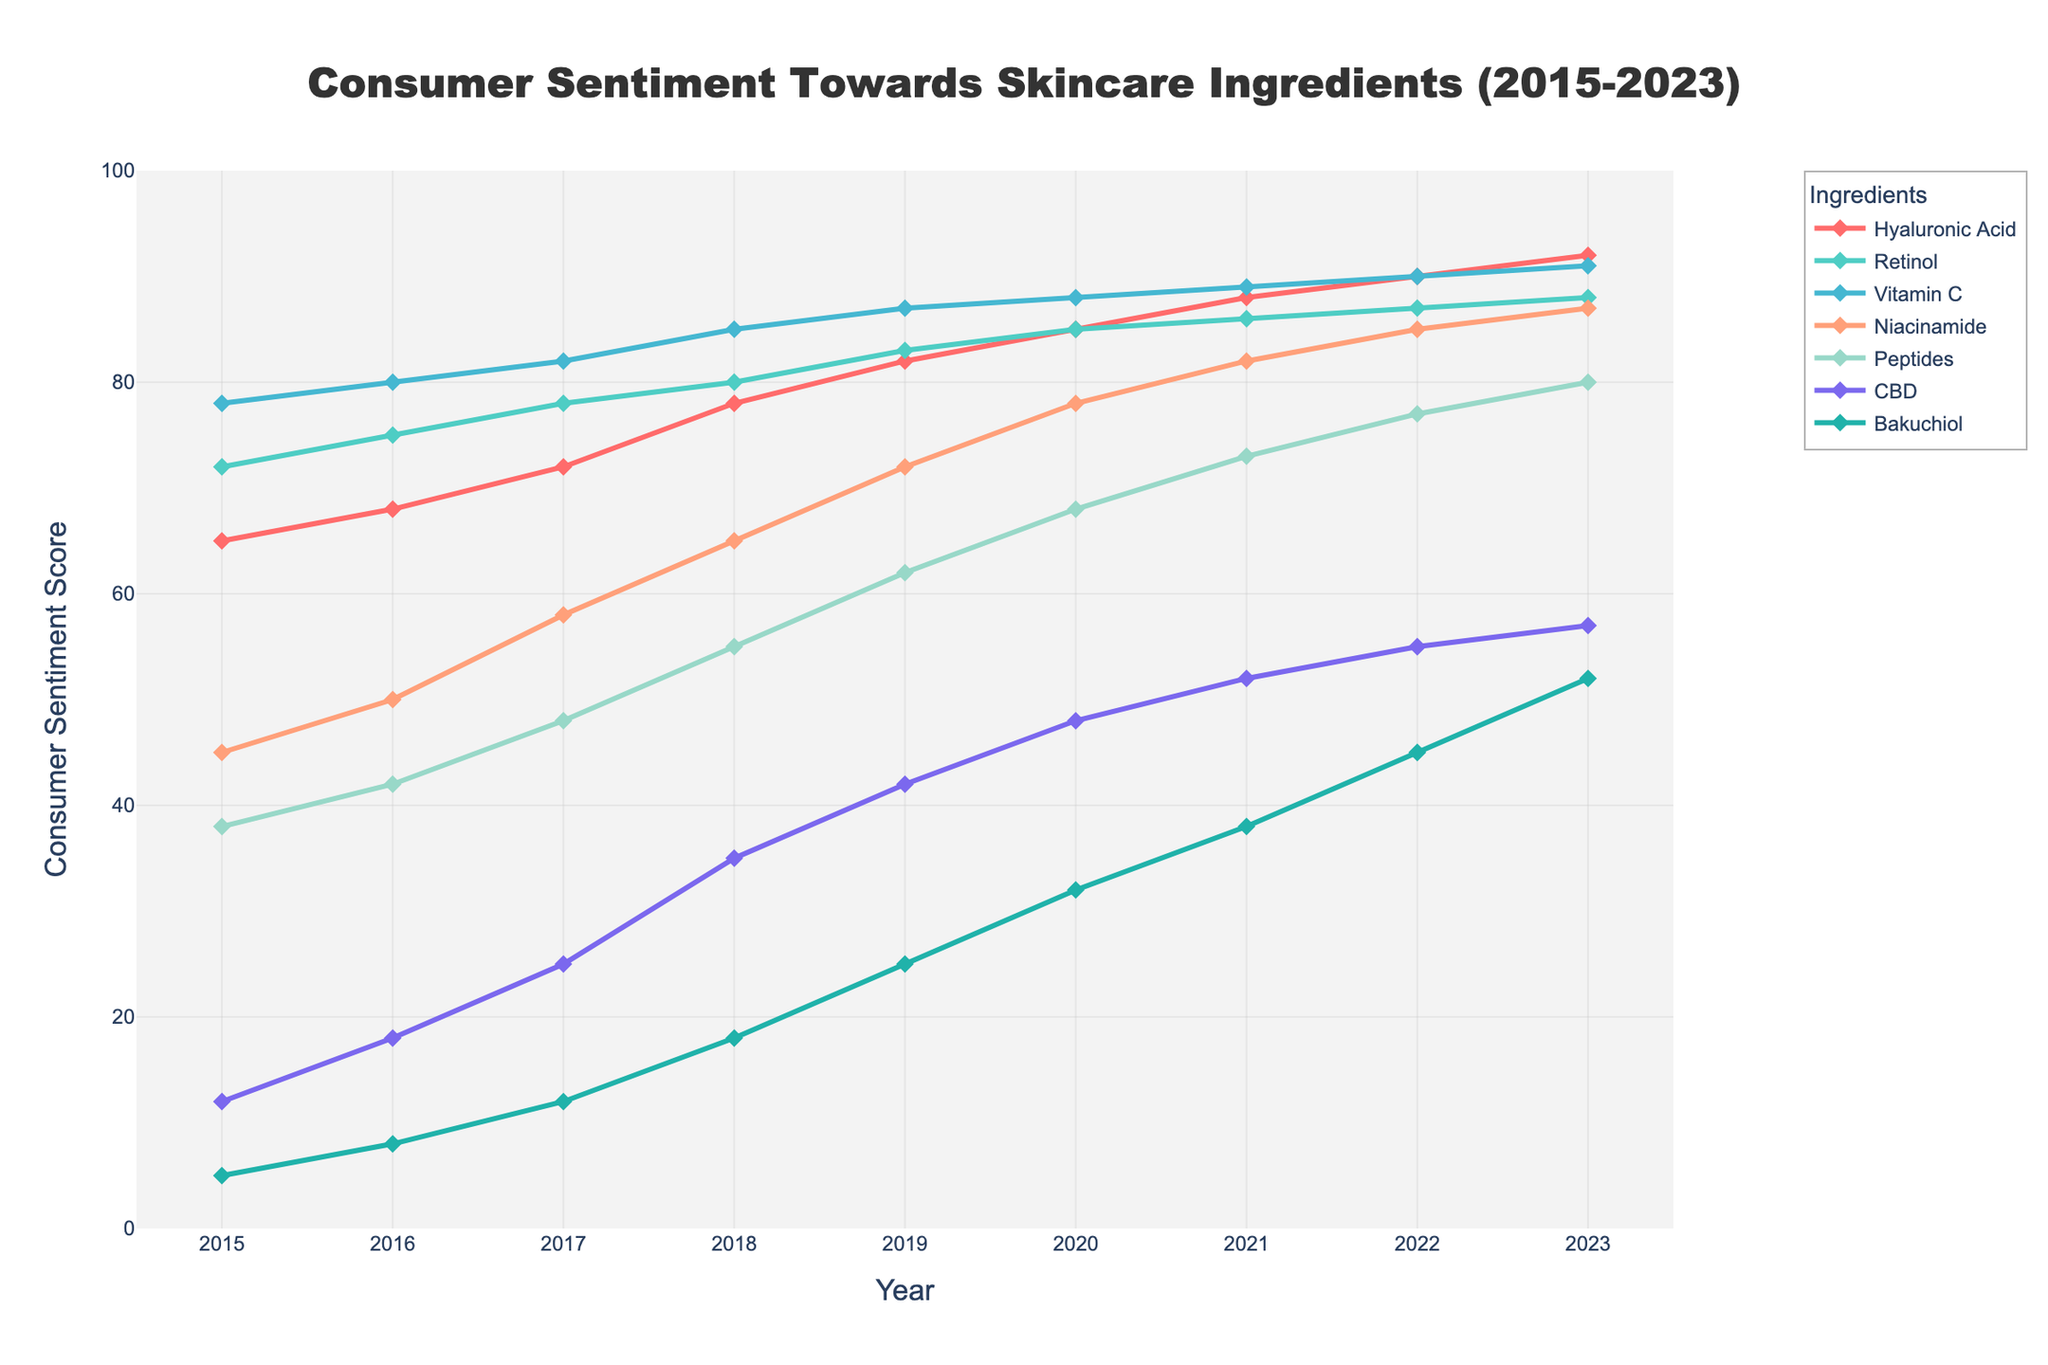What ingredient saw the highest increase in consumer sentiment from 2015 to 2023? To find the ingredient with the highest increase, we calculate the difference in consumer sentiment for each ingredient from 2015 to 2023. The differences are: Hyaluronic Acid (92-65=27), Retinol (88-72=16), Vitamin C (91-78=13), Niacinamide (87-45=42), Peptides (80-38=42), CBD (57-12=45), Bakuchiol (52-5=47). The highest difference is for Bakuchiol.
Answer: Bakuchiol Which year did Vitamin C achieve its highest consumer sentiment score? By looking at the plot, Vitamin C has its highest score where its line peaks. In 2023, Vitamin C reaches a score of 91, its highest on the chart.
Answer: 2023 What was the average consumer sentiment for Niacinamide over the period 2015-2023? The average is calculated by summing all Niacinamide values from 2015 to 2023 and then dividing by the number of years. Sum of Niacinamide scores: 45 + 50 + 58 + 65 + 72 + 78 + 82 + 85 + 87 = 622. There are 9 years, so the average is 622/9 ≈ 69.11
Answer: 69.11 Which ingredient had the lowest consumer sentiment in 2015 and what was its value? By inspecting the 2015 data points, CBD had the lowest score with a value of 12.
Answer: CBD, 12 How did the consumer sentiment for Peptides change from 2015 to 2020? Calculate the difference in sentiment for Peptides from 2015 to 2020: 68 - 38 = 30. Peptides increased by 30 points from 2015 to 2020.
Answer: Increased by 30 points Which two ingredients had the closest consumer sentiment scores in 2022, and what were those scores? Inspecting the 2022 values, Vitamin C (90) and Retinol (87) have scores closest to each other with a difference of 3 points.
Answer: Vitamin C: 90, Retinol: 87 From the given data, what was the total consumer sentiment trend for CBD from 2015 to 2023, and how does it compare with Bakuchiol over the same period? Calculate the total increase; CBD: 57-12=45, Bakuchiol: 52-5=47. While both show significant trends, Bakuchiol's increase (47) slightly outpaces CBD’s (45).
Answer: CBD: +45, Bakuchiol: +47 What is the most consistent upward trend observed among the ingredients over the years? By analyzing the slopes in the chart, CBD shows a very consistent upward trend every year from 2015 (12) to 2023 (57) without any decline.
Answer: CBD Between 2018 and 2020, which ingredient saw the largest improvement in consumer sentiment? Calculate the changes for each ingredient between 2018 and 2020. The changes are: Hyaluronic Acid (85-78=7), Retinol (85-80=5), Vitamin C (88-85=3), Niacinamide (78-65=13), Peptides (68-55=13), CBD (48-35=13), Bakuchiol (32-18=14). Bakuchiol had the largest improvement with an increase of 14 points.
Answer: Bakuchiol 